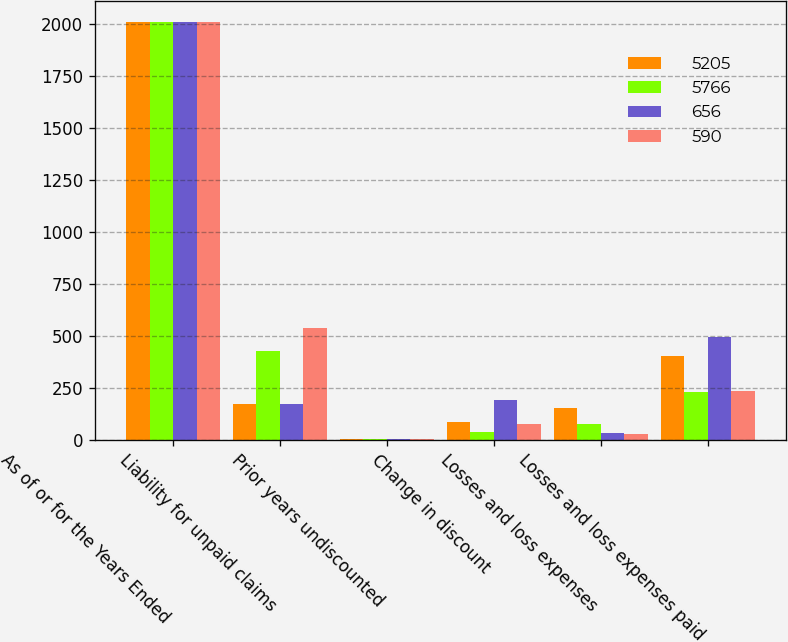<chart> <loc_0><loc_0><loc_500><loc_500><stacked_bar_chart><ecel><fcel>As of or for the Years Ended<fcel>Liability for unpaid claims<fcel>Prior years undiscounted<fcel>Change in discount<fcel>Losses and loss expenses<fcel>Losses and loss expenses paid<nl><fcel>5205<fcel>2012<fcel>170<fcel>1<fcel>83<fcel>150<fcel>404<nl><fcel>5766<fcel>2012<fcel>427<fcel>1<fcel>37<fcel>75<fcel>228<nl><fcel>656<fcel>2011<fcel>170<fcel>2<fcel>190<fcel>33<fcel>492<nl><fcel>590<fcel>2011<fcel>537<fcel>2<fcel>74<fcel>27<fcel>236<nl></chart> 